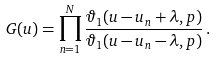<formula> <loc_0><loc_0><loc_500><loc_500>G ( u ) = \prod _ { n = 1 } ^ { N } \frac { \vartheta _ { 1 } ( u - u _ { n } + \lambda , p ) } { \vartheta _ { 1 } ( u - u _ { n } - \lambda , p ) } \, .</formula> 